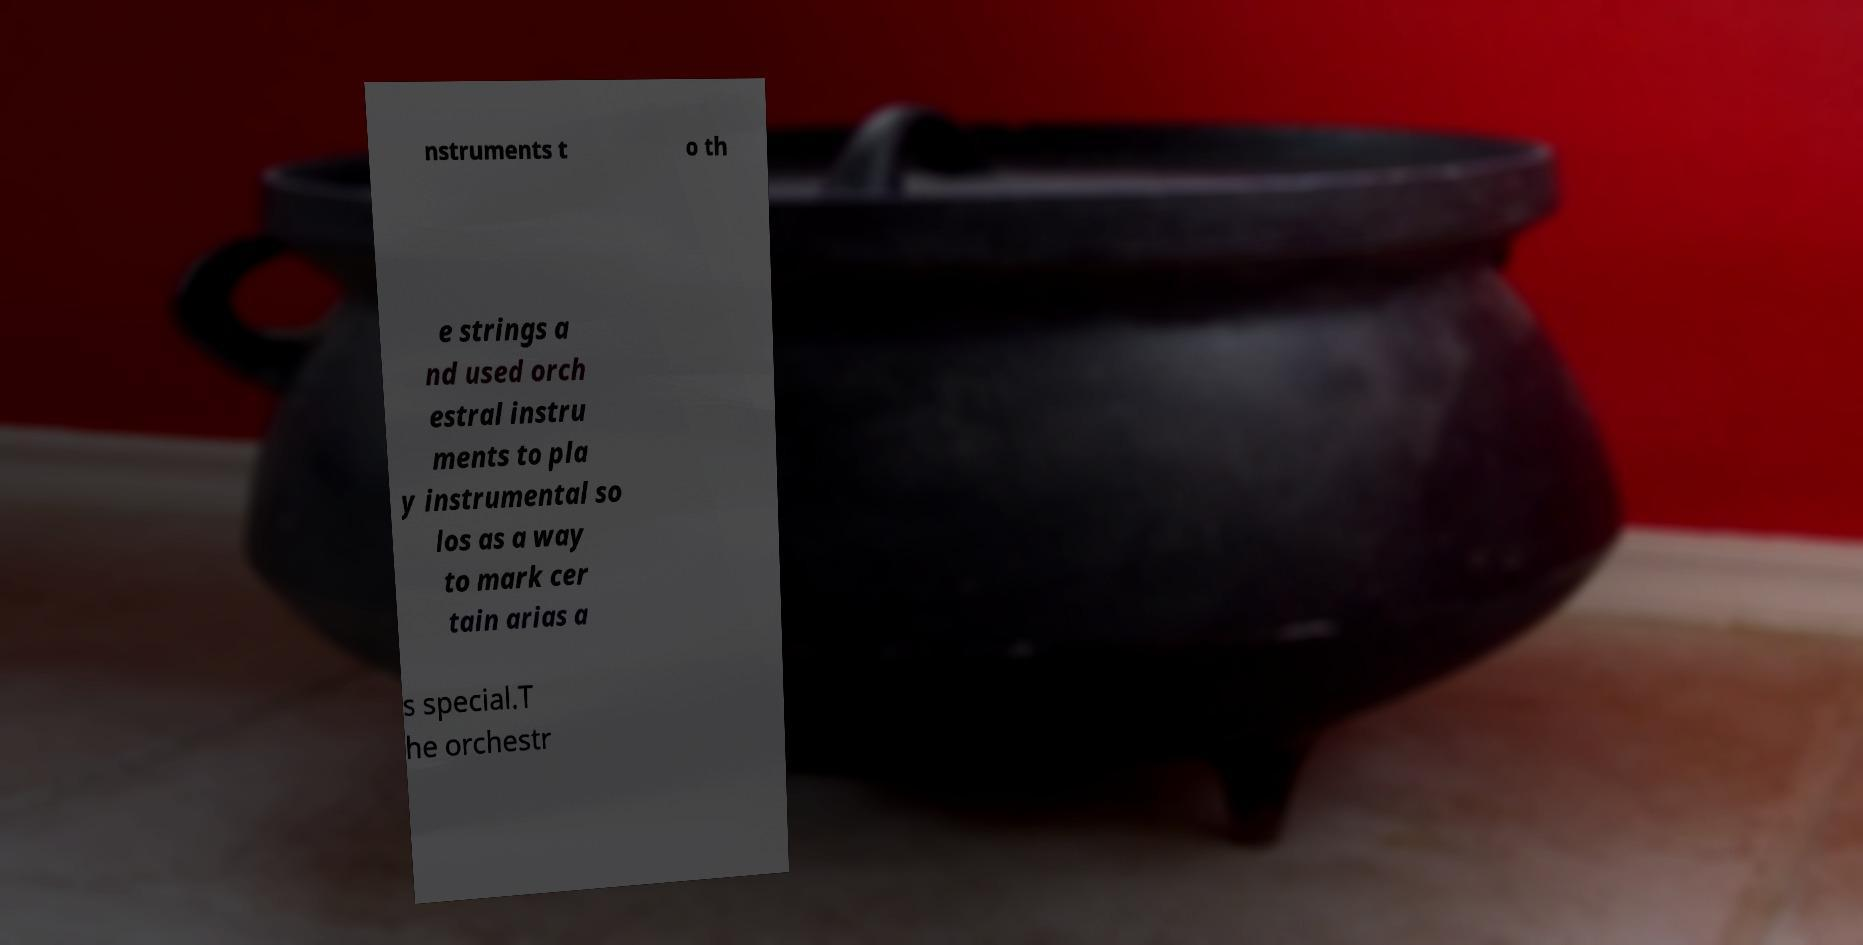I need the written content from this picture converted into text. Can you do that? nstruments t o th e strings a nd used orch estral instru ments to pla y instrumental so los as a way to mark cer tain arias a s special.T he orchestr 